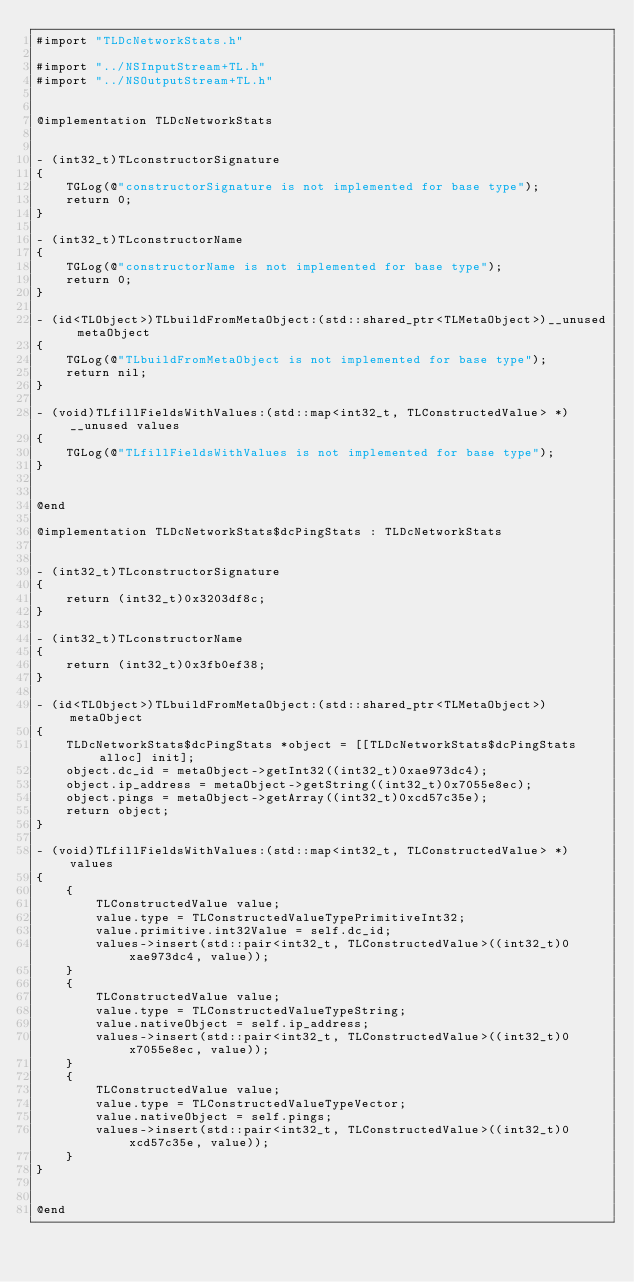<code> <loc_0><loc_0><loc_500><loc_500><_ObjectiveC_>#import "TLDcNetworkStats.h"

#import "../NSInputStream+TL.h"
#import "../NSOutputStream+TL.h"


@implementation TLDcNetworkStats


- (int32_t)TLconstructorSignature
{
    TGLog(@"constructorSignature is not implemented for base type");
    return 0;
}

- (int32_t)TLconstructorName
{
    TGLog(@"constructorName is not implemented for base type");
    return 0;
}

- (id<TLObject>)TLbuildFromMetaObject:(std::shared_ptr<TLMetaObject>)__unused metaObject
{
    TGLog(@"TLbuildFromMetaObject is not implemented for base type");
    return nil;
}

- (void)TLfillFieldsWithValues:(std::map<int32_t, TLConstructedValue> *)__unused values
{
    TGLog(@"TLfillFieldsWithValues is not implemented for base type");
}


@end

@implementation TLDcNetworkStats$dcPingStats : TLDcNetworkStats


- (int32_t)TLconstructorSignature
{
    return (int32_t)0x3203df8c;
}

- (int32_t)TLconstructorName
{
    return (int32_t)0x3fb0ef38;
}

- (id<TLObject>)TLbuildFromMetaObject:(std::shared_ptr<TLMetaObject>)metaObject
{
    TLDcNetworkStats$dcPingStats *object = [[TLDcNetworkStats$dcPingStats alloc] init];
    object.dc_id = metaObject->getInt32((int32_t)0xae973dc4);
    object.ip_address = metaObject->getString((int32_t)0x7055e8ec);
    object.pings = metaObject->getArray((int32_t)0xcd57c35e);
    return object;
}

- (void)TLfillFieldsWithValues:(std::map<int32_t, TLConstructedValue> *)values
{
    {
        TLConstructedValue value;
        value.type = TLConstructedValueTypePrimitiveInt32;
        value.primitive.int32Value = self.dc_id;
        values->insert(std::pair<int32_t, TLConstructedValue>((int32_t)0xae973dc4, value));
    }
    {
        TLConstructedValue value;
        value.type = TLConstructedValueTypeString;
        value.nativeObject = self.ip_address;
        values->insert(std::pair<int32_t, TLConstructedValue>((int32_t)0x7055e8ec, value));
    }
    {
        TLConstructedValue value;
        value.type = TLConstructedValueTypeVector;
        value.nativeObject = self.pings;
        values->insert(std::pair<int32_t, TLConstructedValue>((int32_t)0xcd57c35e, value));
    }
}


@end

</code> 